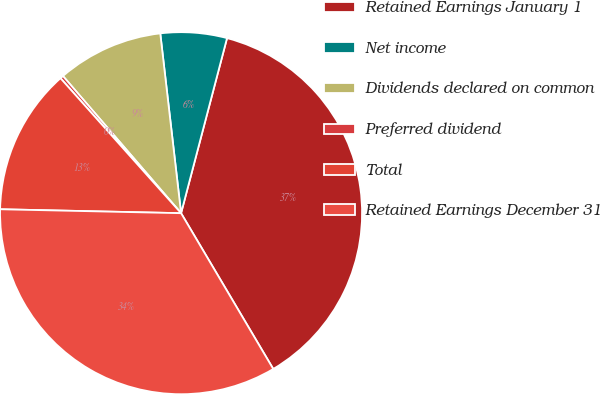Convert chart. <chart><loc_0><loc_0><loc_500><loc_500><pie_chart><fcel>Retained Earnings January 1<fcel>Net income<fcel>Dividends declared on common<fcel>Preferred dividend<fcel>Total<fcel>Retained Earnings December 31<nl><fcel>37.41%<fcel>5.92%<fcel>9.48%<fcel>0.29%<fcel>13.05%<fcel>33.85%<nl></chart> 